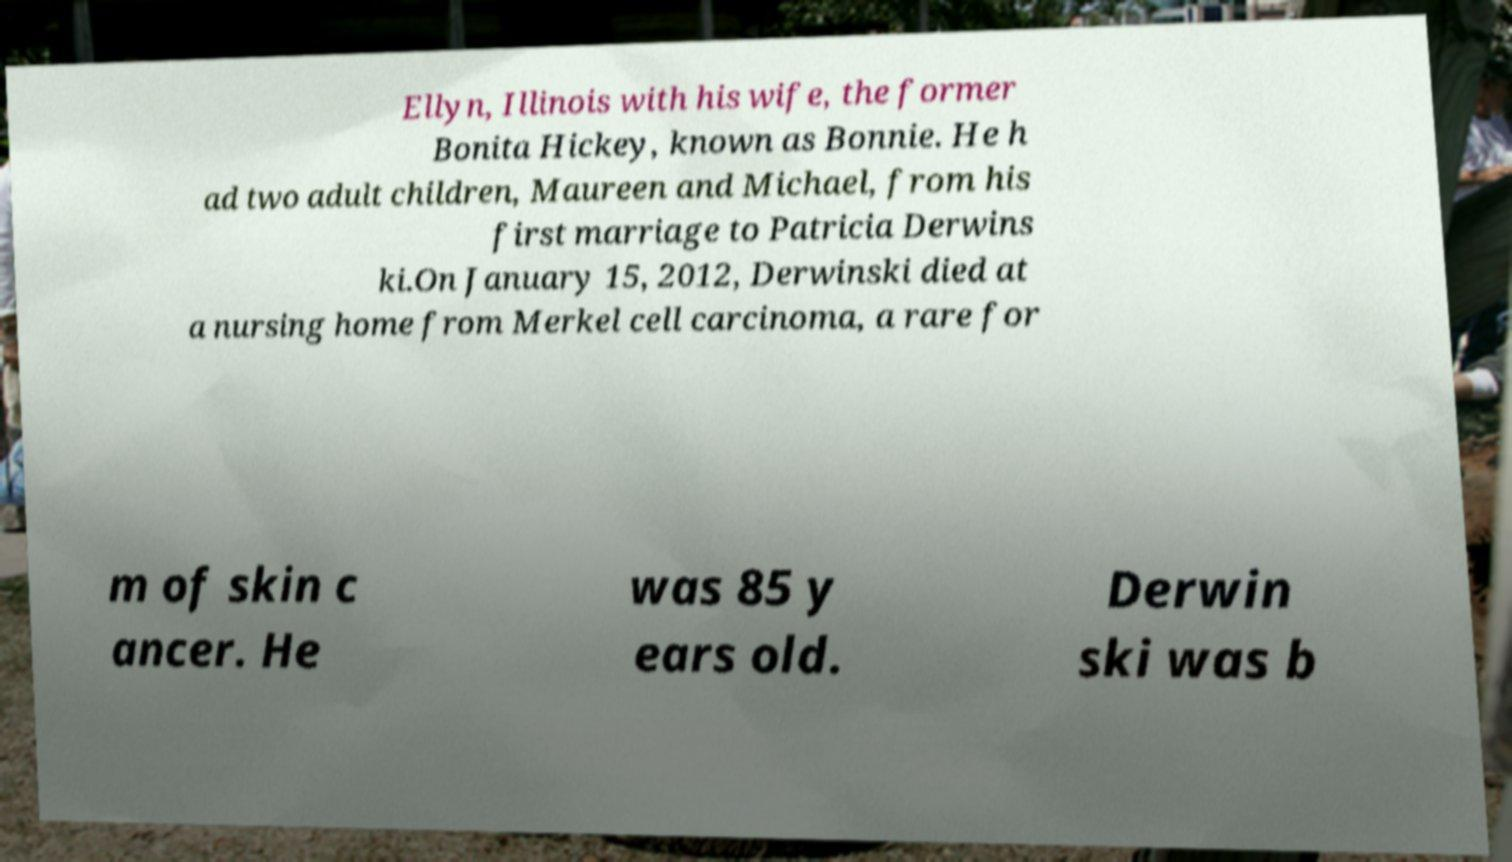For documentation purposes, I need the text within this image transcribed. Could you provide that? Ellyn, Illinois with his wife, the former Bonita Hickey, known as Bonnie. He h ad two adult children, Maureen and Michael, from his first marriage to Patricia Derwins ki.On January 15, 2012, Derwinski died at a nursing home from Merkel cell carcinoma, a rare for m of skin c ancer. He was 85 y ears old. Derwin ski was b 